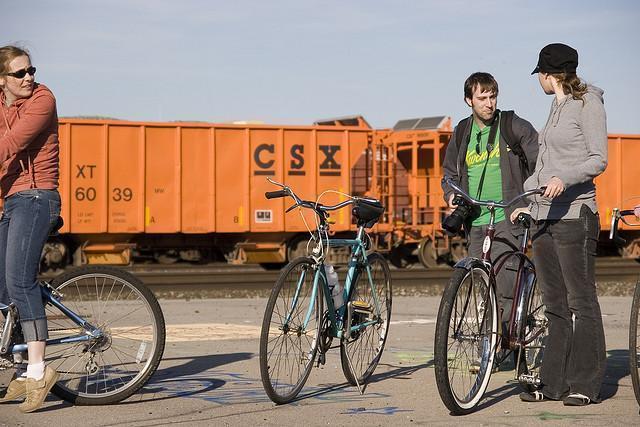How many motors are on the vehicles used by the people shown here to get them here?
Make your selection and explain in format: 'Answer: answer
Rationale: rationale.'
Options: Two, three, three, none. Answer: none.
Rationale: All of these people are standing around their bicycles. they don't require any engines to move. 